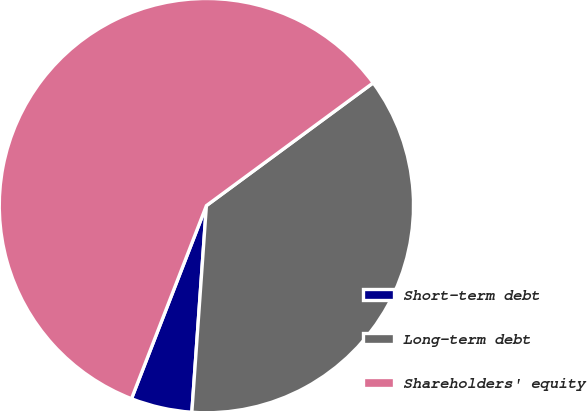Convert chart to OTSL. <chart><loc_0><loc_0><loc_500><loc_500><pie_chart><fcel>Short-term debt<fcel>Long-term debt<fcel>Shareholders' equity<nl><fcel>4.77%<fcel>36.22%<fcel>59.01%<nl></chart> 